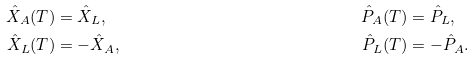Convert formula to latex. <formula><loc_0><loc_0><loc_500><loc_500>\hat { X } _ { A } ( T ) & = \hat { X } _ { L } , & \hat { P } _ { A } ( T ) & = \hat { P } _ { L } , \\ \hat { X } _ { L } ( T ) & = - \hat { X } _ { A } , & \hat { P } _ { L } ( T ) & = - \hat { P } _ { A } .</formula> 